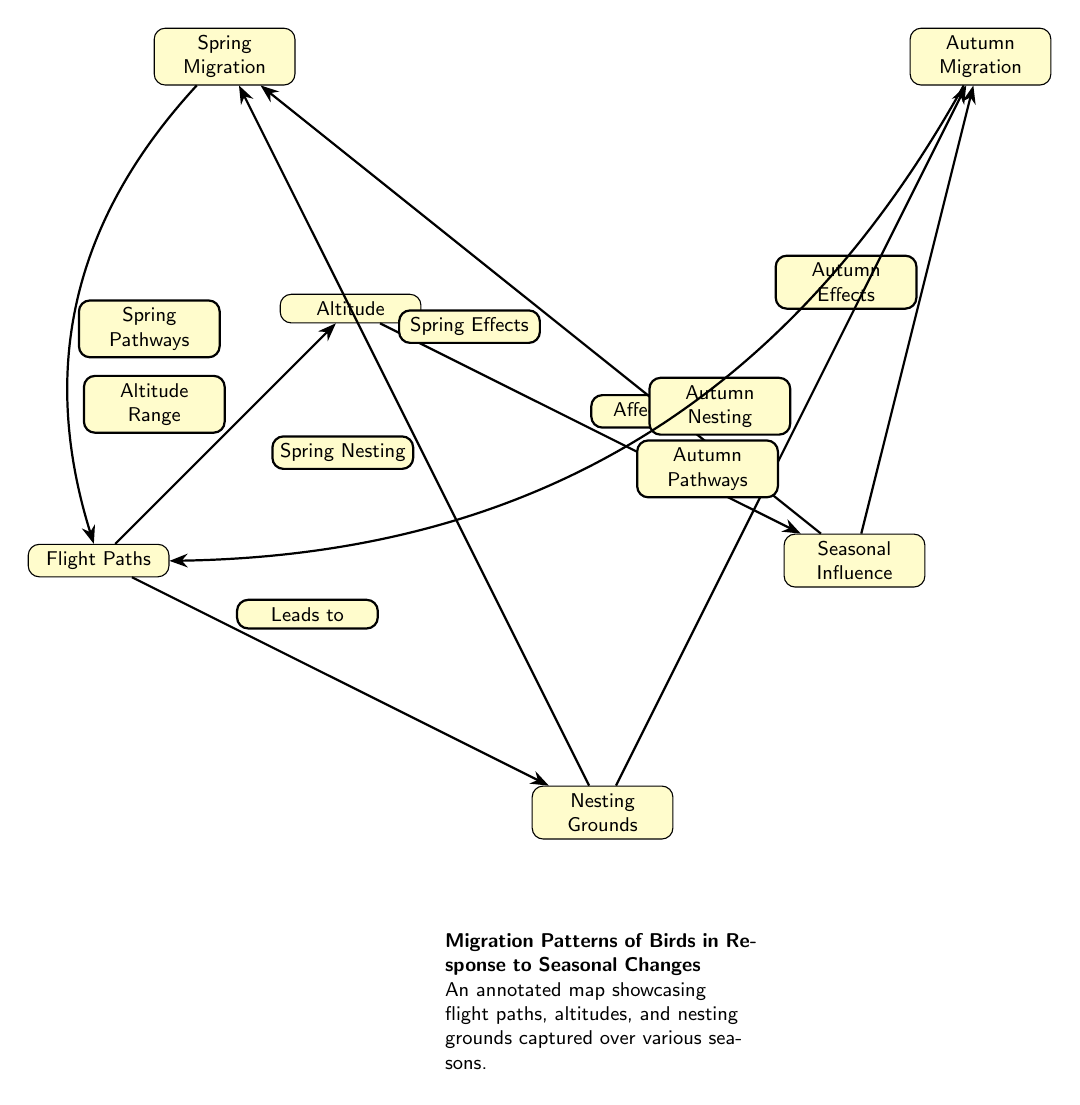What are the two main types of migration depicted? The diagram explicitly labels "Spring Migration" and "Autumn Migration" as the two main types of migration, distinguishing the typical seasonal behaviors of birds.
Answer: Spring Migration, Autumn Migration How many nodes are present in this diagram? By counting each labeled node in the diagram, we find that there are a total of six nodes: Flight Paths, Nesting Grounds, Altitude, Seasonal Influence, Spring Migration, and Autumn Migration.
Answer: 6 What does "Altitude" affect? According to the diagram, "Altitude" is indicated to be "Affected by" the node labeled "Seasonal Influence," highlighting its dependence on seasonal changes.
Answer: Seasonal Influence What do "Spring Nesting" and "Autumn Nesting" connect to? The diagram shows that "Spring Nesting" connects to "Spring Migration" and "Autumn Nesting" connects to "Autumn Migration," illustrating where nesting occurs during these seasons.
Answer: Spring Migration, Autumn Migration Which pathways are described as "Spring Pathways"? The diagram states that "Spring Pathways" refers to the paths that birds take during the spring season, specifically from the node "Spring Migration" directed towards "Flight Paths."
Answer: Flight Paths What is the relationship between "Flight Paths" and "Nesting Grounds"? The connection is indicated by the edge labeled "Leads to," meaning that the identified flight paths contribute to accessing nesting grounds for the birds.
Answer: Leads to Which node has an edge labeled "Affected by"? The node "Altitude" has an edge connecting it with the label "Affected by," signifying that altitude is influenced by the conditions described in the node it connects to.
Answer: Altitude What seasonal effects are noted in this diagram? The diagram differentiates between "Spring Effects" and "Autumn Effects," indicating that the seasonal changes impact the migration behavior and nesting of birds in these two distinct periods.
Answer: Spring Effects, Autumn Effects How are the relationship dynamics between "Nesting Grounds" and seasonal migrations illustrated? The diagram depicts that "Nesting Grounds" are influenced by either "Spring Nesting" or "Autumn Nesting," emphasizing how different nesting behaviors correspond to seasonal migrations.
Answer: Spring Nesting, Autumn Nesting 